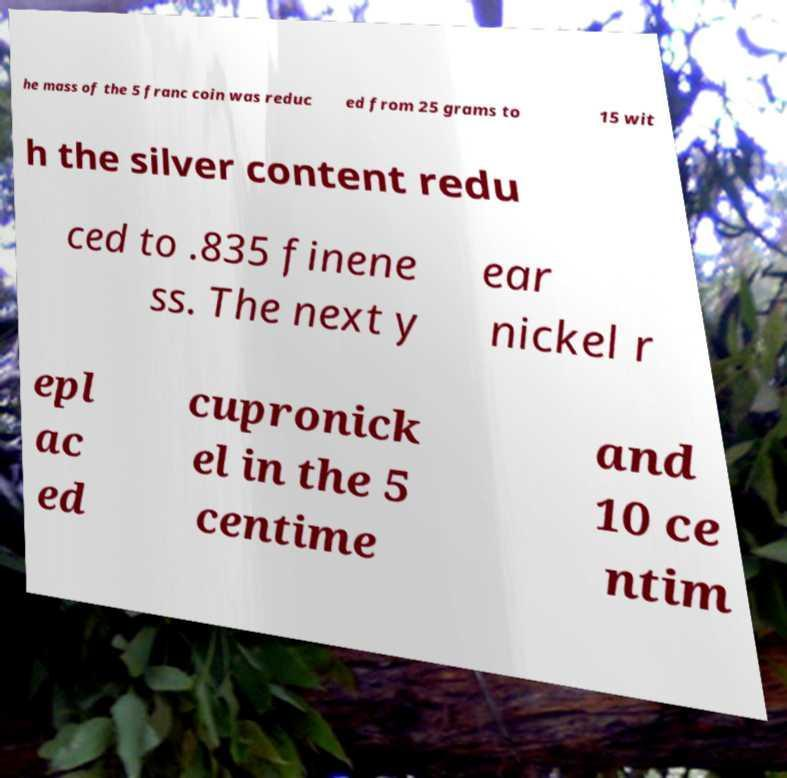I need the written content from this picture converted into text. Can you do that? he mass of the 5 franc coin was reduc ed from 25 grams to 15 wit h the silver content redu ced to .835 finene ss. The next y ear nickel r epl ac ed cupronick el in the 5 centime and 10 ce ntim 